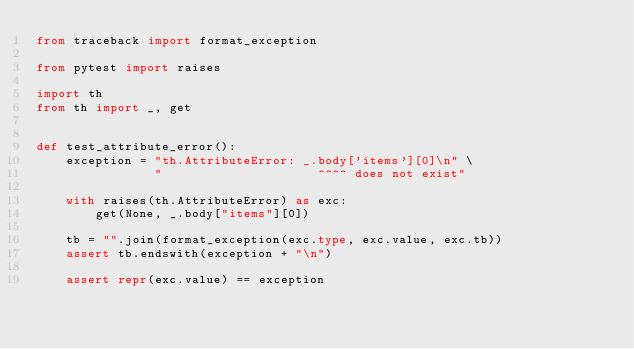Convert code to text. <code><loc_0><loc_0><loc_500><loc_500><_Python_>from traceback import format_exception

from pytest import raises

import th
from th import _, get


def test_attribute_error():
    exception = "th.AttributeError: _.body['items'][0]\n" \
                "                     ^^^^ does not exist"

    with raises(th.AttributeError) as exc:
        get(None, _.body["items"][0])

    tb = "".join(format_exception(exc.type, exc.value, exc.tb))
    assert tb.endswith(exception + "\n")

    assert repr(exc.value) == exception

</code> 